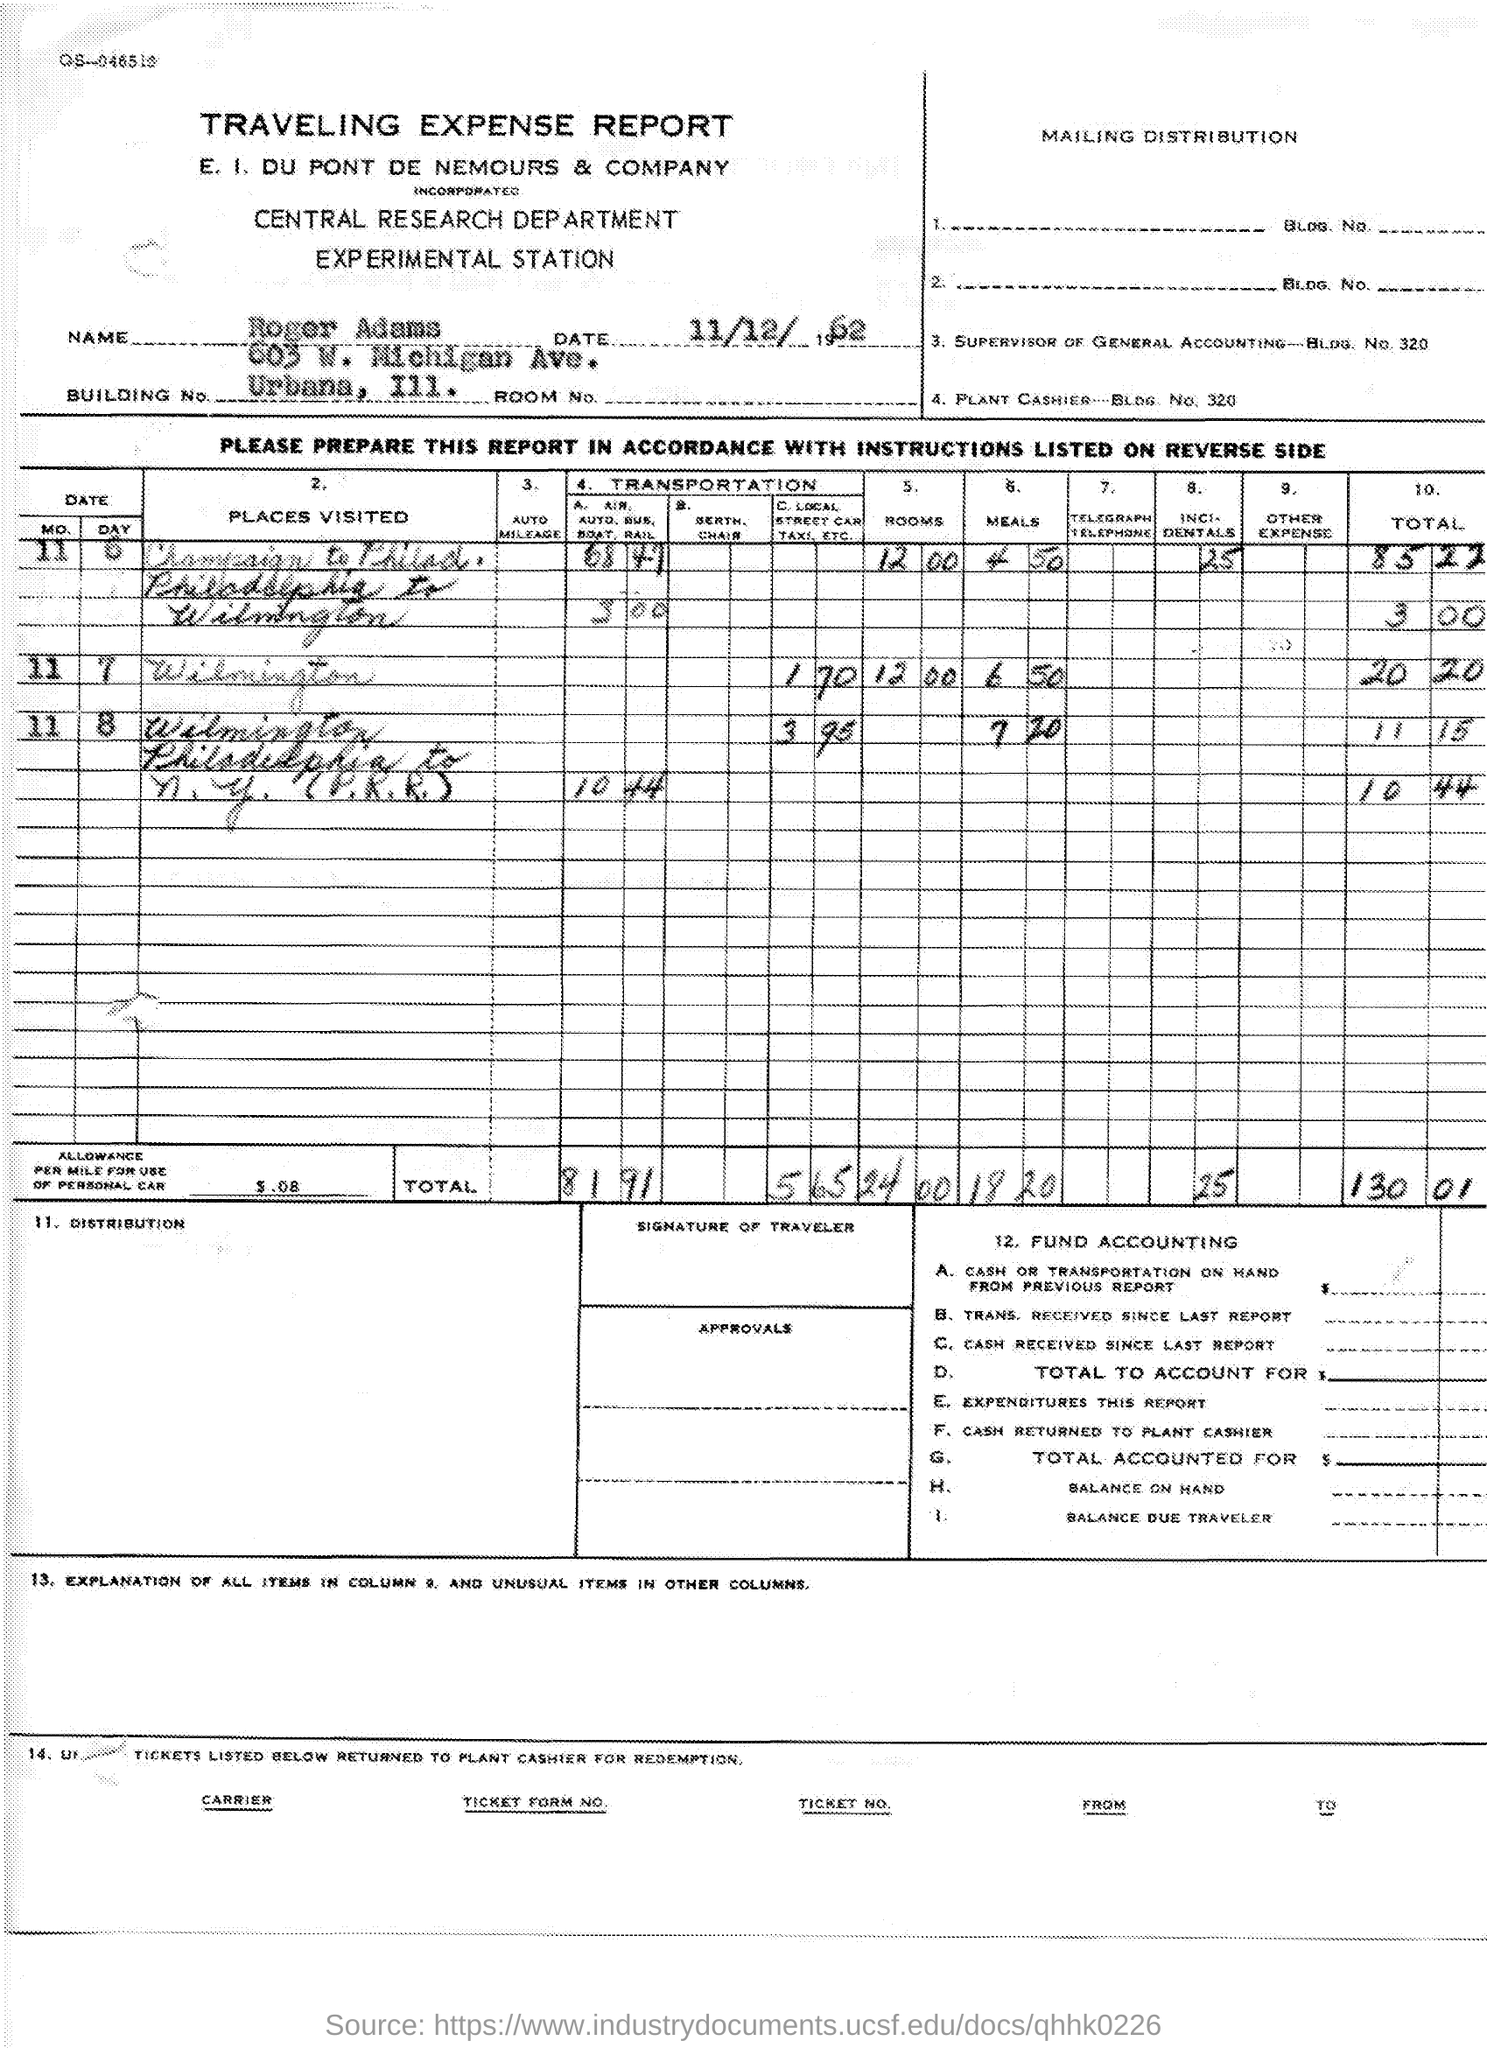Give some essential details in this illustration. The date mentioned in the given report is 11/12/1962. The name mentioned in the given report is Roger Adams. The Central Research Department is the name of the department mentioned in the given report. 